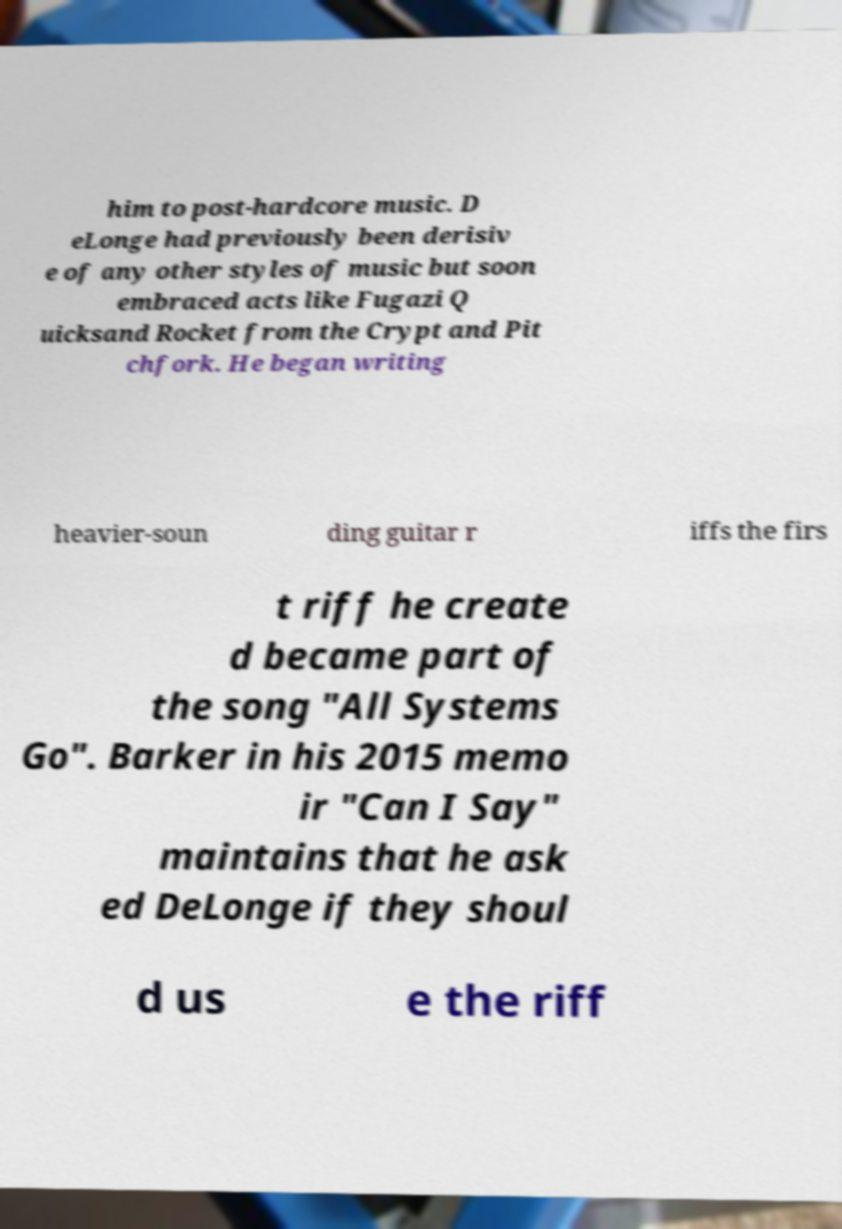Could you extract and type out the text from this image? him to post-hardcore music. D eLonge had previously been derisiv e of any other styles of music but soon embraced acts like Fugazi Q uicksand Rocket from the Crypt and Pit chfork. He began writing heavier-soun ding guitar r iffs the firs t riff he create d became part of the song "All Systems Go". Barker in his 2015 memo ir "Can I Say" maintains that he ask ed DeLonge if they shoul d us e the riff 